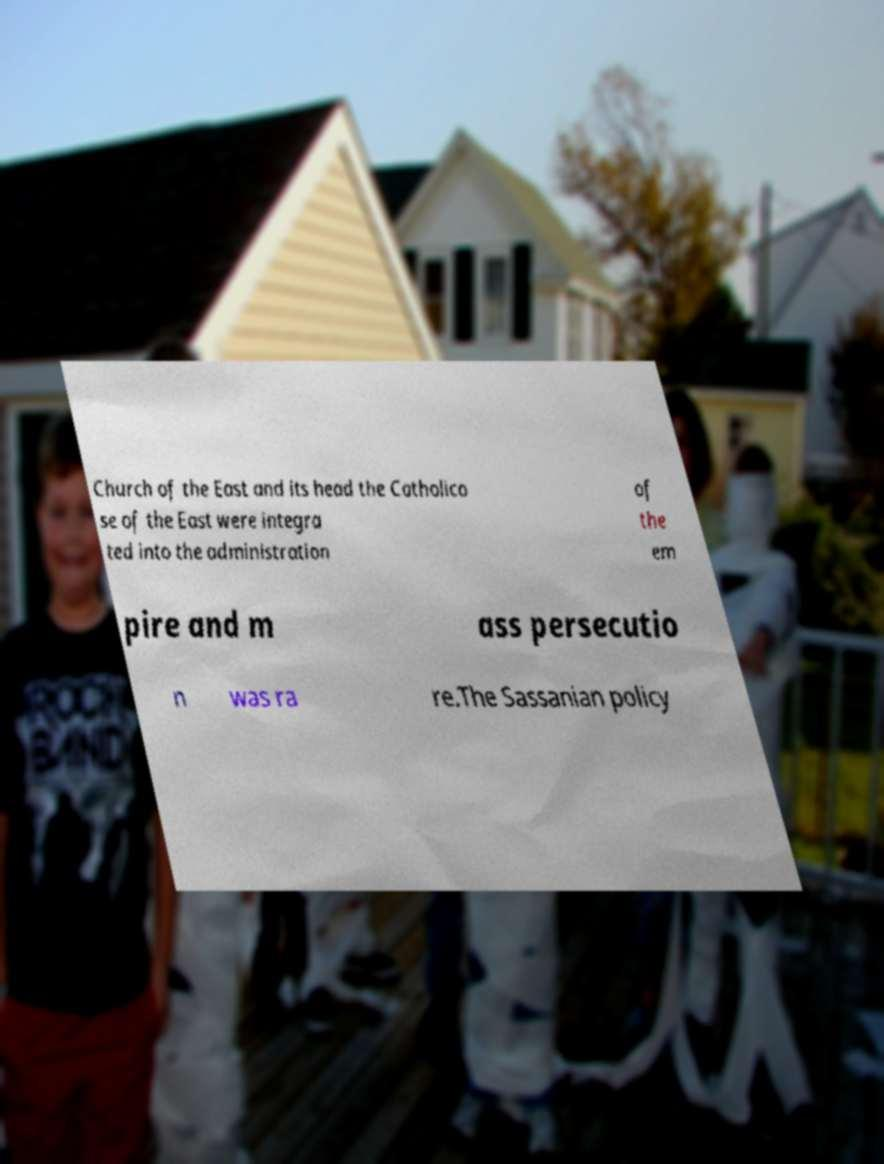For documentation purposes, I need the text within this image transcribed. Could you provide that? Church of the East and its head the Catholico se of the East were integra ted into the administration of the em pire and m ass persecutio n was ra re.The Sassanian policy 